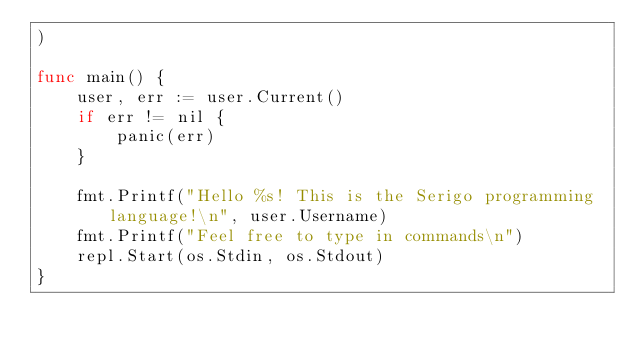Convert code to text. <code><loc_0><loc_0><loc_500><loc_500><_Go_>)

func main() {
	user, err := user.Current()
	if err != nil {
		panic(err)
	}

	fmt.Printf("Hello %s! This is the Serigo programming language!\n", user.Username)
	fmt.Printf("Feel free to type in commands\n")
	repl.Start(os.Stdin, os.Stdout)
}
</code> 